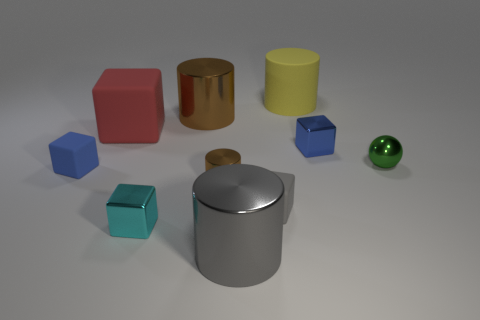What is the shape of the small cyan shiny object?
Ensure brevity in your answer.  Cube. How many blocks are either large metallic objects or gray matte objects?
Make the answer very short. 1. Are there the same number of tiny green balls that are behind the green metal ball and big gray shiny things to the left of the tiny cyan shiny thing?
Offer a terse response. Yes. There is a shiny cube in front of the shiny cube behind the tiny brown cylinder; what number of metal spheres are on the left side of it?
Provide a short and direct response. 0. What is the shape of the large object that is the same color as the small cylinder?
Offer a very short reply. Cylinder. Is the color of the small metal cylinder the same as the large metal cylinder behind the tiny shiny ball?
Your response must be concise. Yes. Is the number of small cubes that are on the left side of the rubber cylinder greater than the number of tiny cyan objects?
Make the answer very short. Yes. How many things are either big metallic cylinders that are behind the small brown metal thing or things behind the small cyan cube?
Keep it short and to the point. 8. What size is the yellow cylinder that is the same material as the large red thing?
Keep it short and to the point. Large. There is a small blue object that is on the right side of the big gray metal object; does it have the same shape as the tiny green object?
Ensure brevity in your answer.  No. 